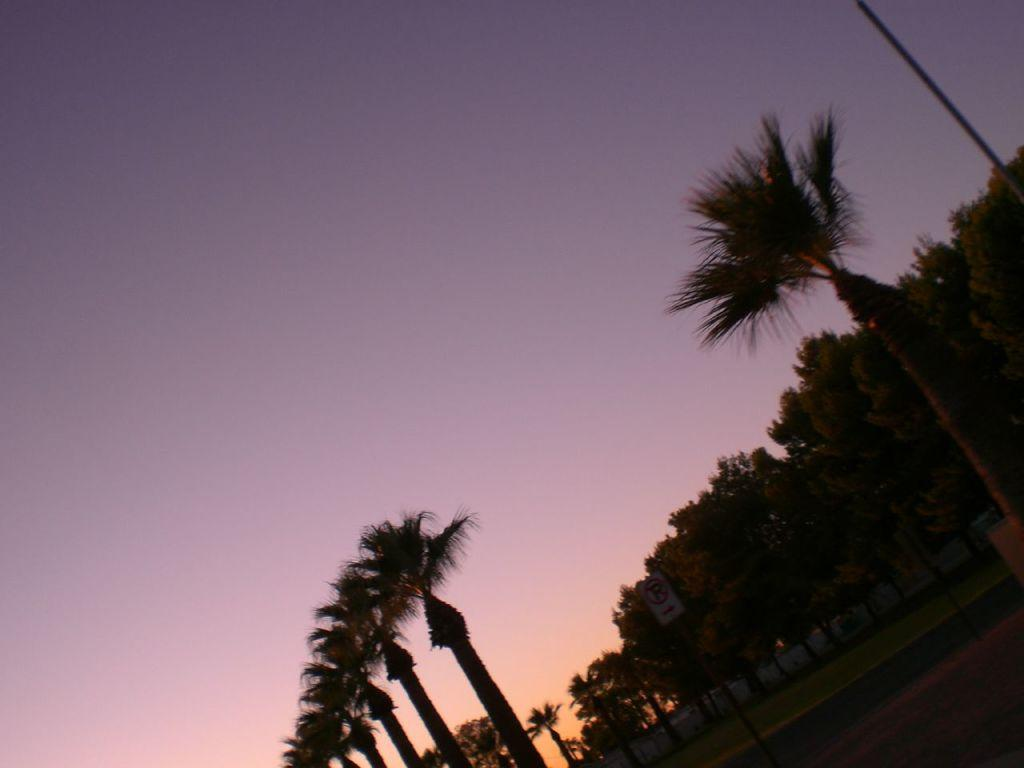What type of vegetation can be seen in the image? There are trees and grass in the image. What structure is present in the image? There is a pole in the image. What surface is visible in the image? There is a board in the image. What type of terrain is present in the bottom right hand corner of the image? There is sand in the bottom right hand corner of the image. What part of the natural environment is visible at the top of the image? The sky is visible at the top of the image. How many leaves can be seen on the trees in the image? There is no mention of leaves on the trees in the image, so we cannot determine the number of leaves. What color is the eye of the person in the image? There is no person or eye present in the image. 